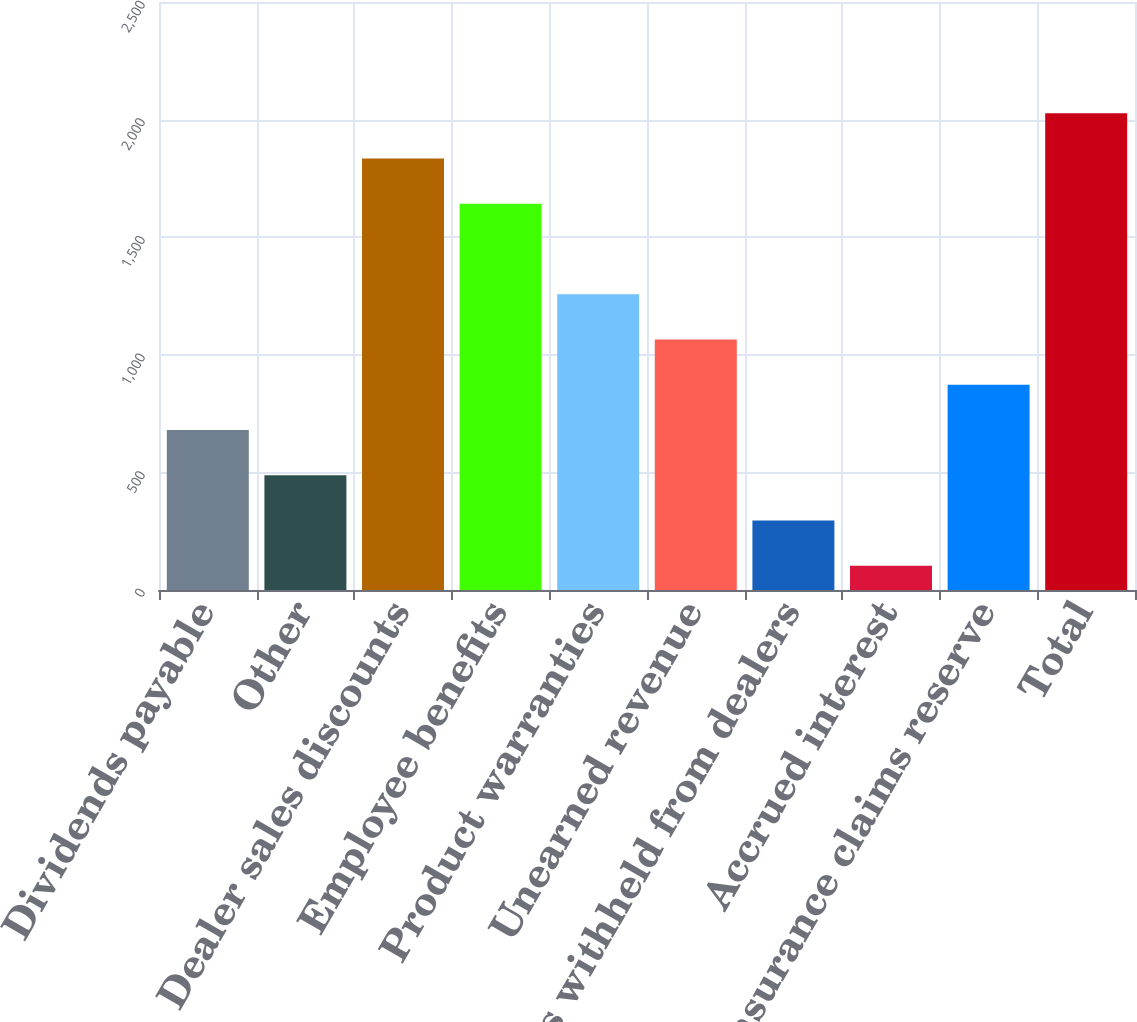Convert chart. <chart><loc_0><loc_0><loc_500><loc_500><bar_chart><fcel>Dividends payable<fcel>Other<fcel>Dealer sales discounts<fcel>Employee benefits<fcel>Product warranties<fcel>Unearned revenue<fcel>Deposits withheld from dealers<fcel>Accrued interest<fcel>Insurance claims reserve<fcel>Total<nl><fcel>680.2<fcel>487.8<fcel>1834.6<fcel>1642.2<fcel>1257.4<fcel>1065<fcel>295.4<fcel>103<fcel>872.6<fcel>2027<nl></chart> 